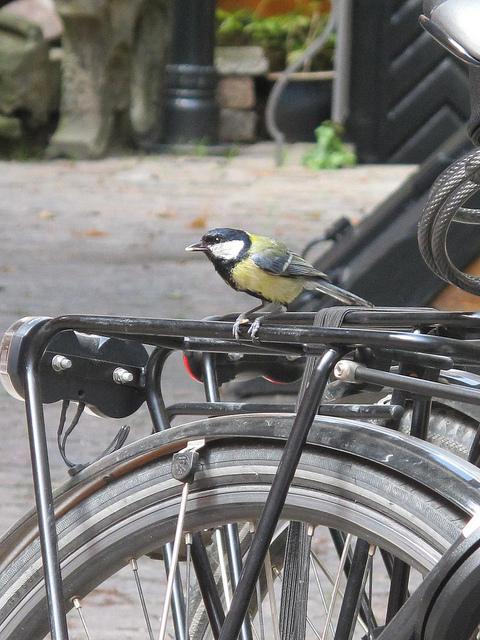Is this a flock of birds?
Quick response, please. No. Is it raining?
Be succinct. No. What color is the bike?
Concise answer only. Black. Is the bird sitting on top of a bike?
Answer briefly. Yes. What type of vehicle might this be?
Write a very short answer. Bike. 